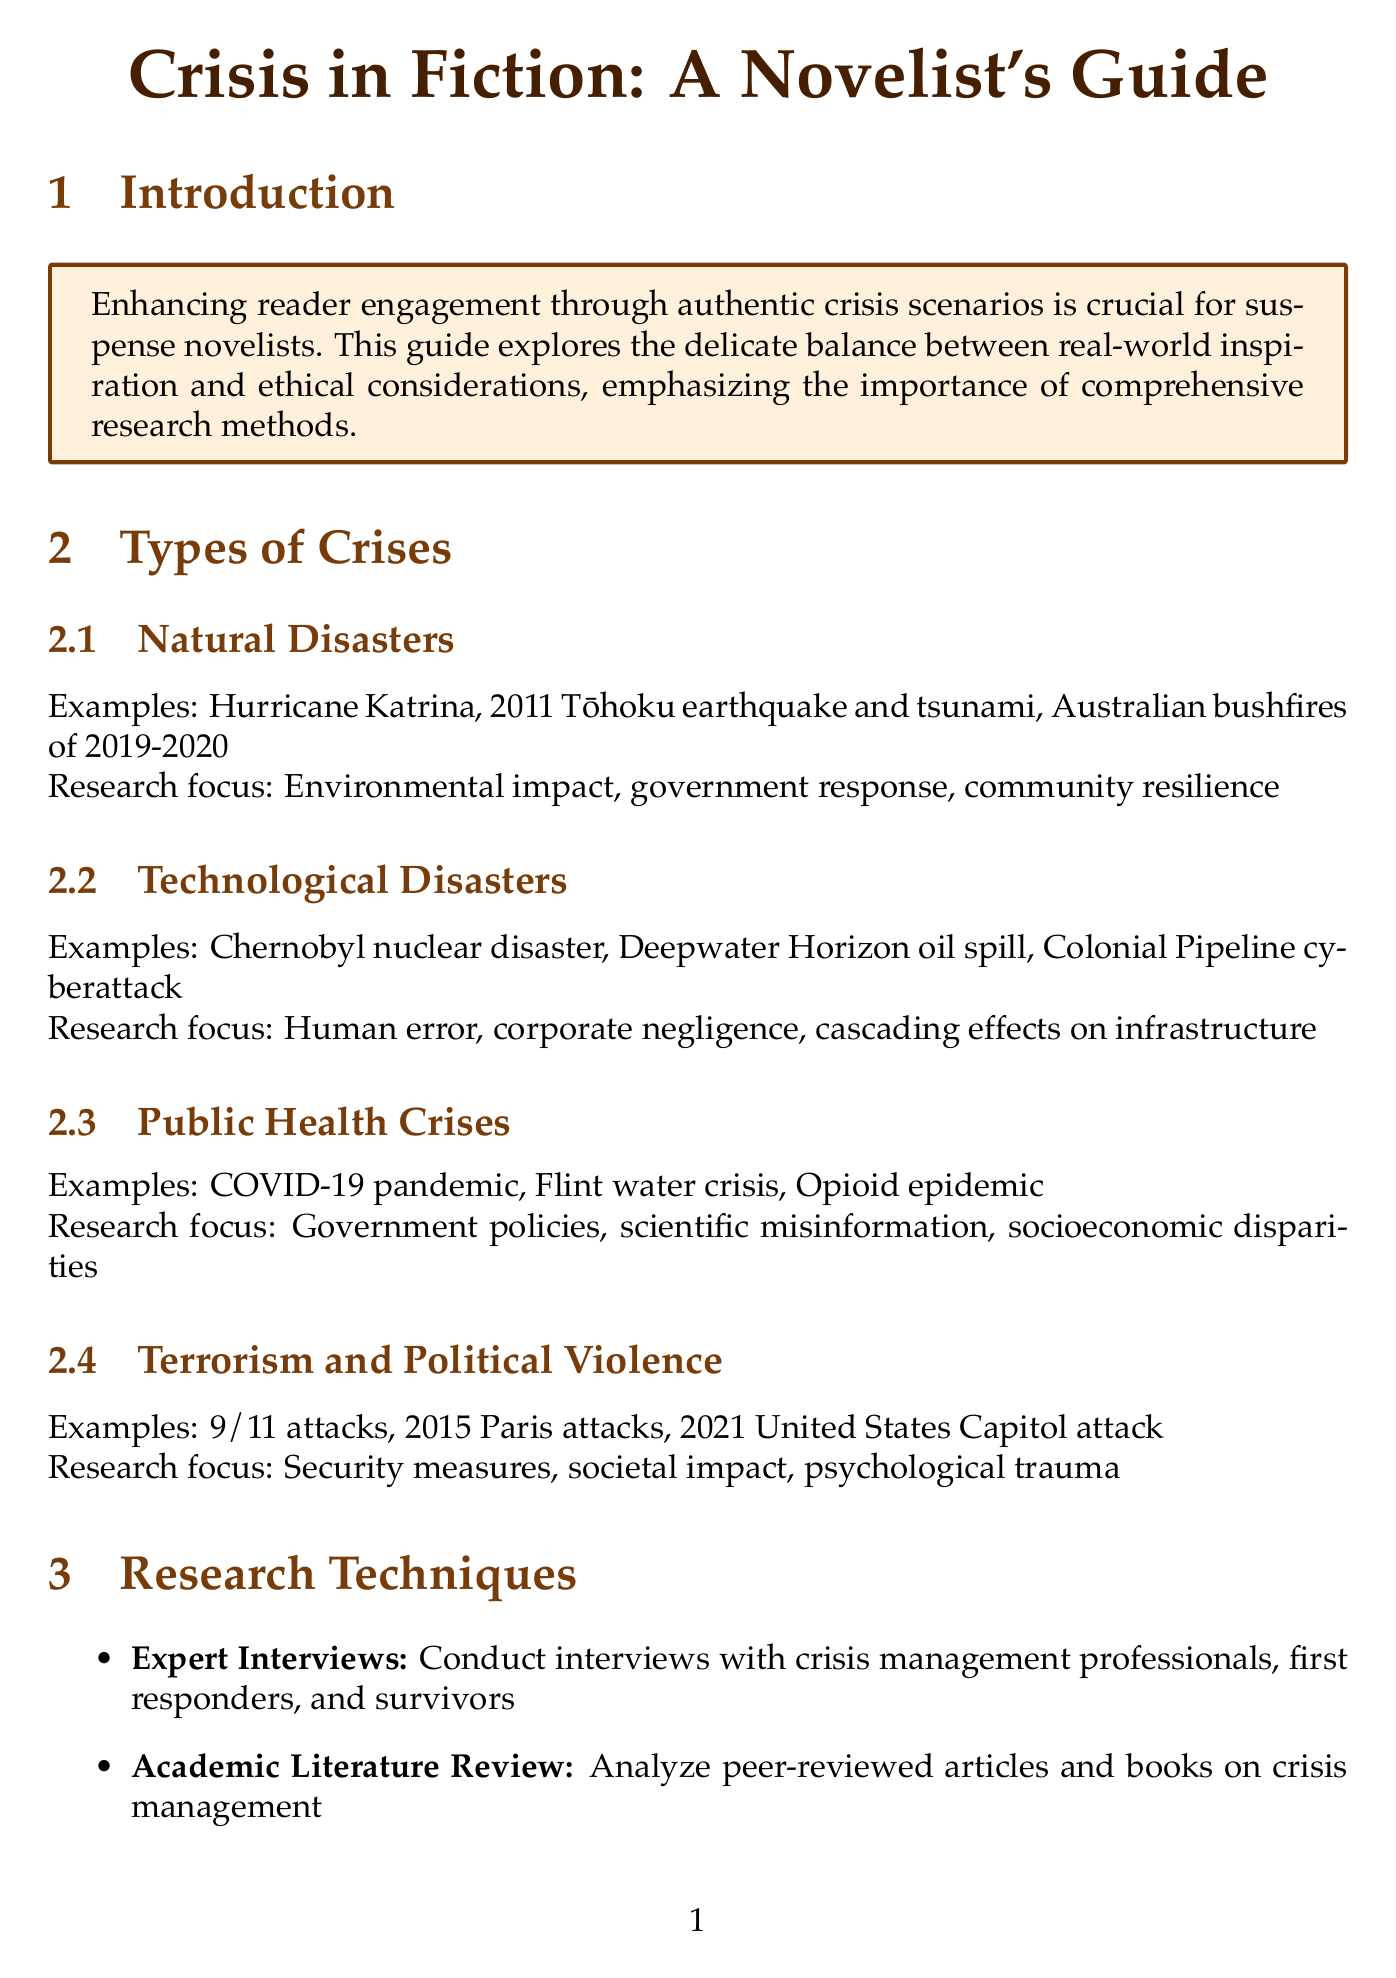What is the title of the manual? The title of the manual is the first line of the document, which provides the overall theme of the content.
Answer: Crisis in Fiction: A Novelist's Guide What is one example of a natural disaster listed? The document provides specific examples under the natural disasters category, which enhances its informative content.
Answer: Hurricane Katrina What is the research focus for public health crises? The document outlines specific research focuses for each crisis type, clarifying the areas of study for authors.
Answer: Government policies, scientific misinformation, socioeconomic disparities How many types of crises are discussed in the document? By reviewing the sections, the total number of crisis types can be determined, reflecting the range of scenarios covered.
Answer: Four What is a key ethical consideration in writing about crises? The document lists specific ethical considerations, highlighting the importance of sensitivity and respect in the portrayal of real-world events.
Answer: Victim Sensitivity Who is interviewed in the expert interview example? The document provides an example of an expert interview, which illustrates a method of gathering authentic insights for writing.
Answer: Craig Fugate What type of exercise involves creating a timeline? The document lists various writing exercises aimed at enhancing the author's skills and engagement with the research.
Answer: Crisis Timeline Reconstruction In which case study title is an intelligence failure discussed? The case studies section details specific works that illustrate the incorporation of real-world events into fiction.
Answer: The Looming Tower by Lawrence Wright 